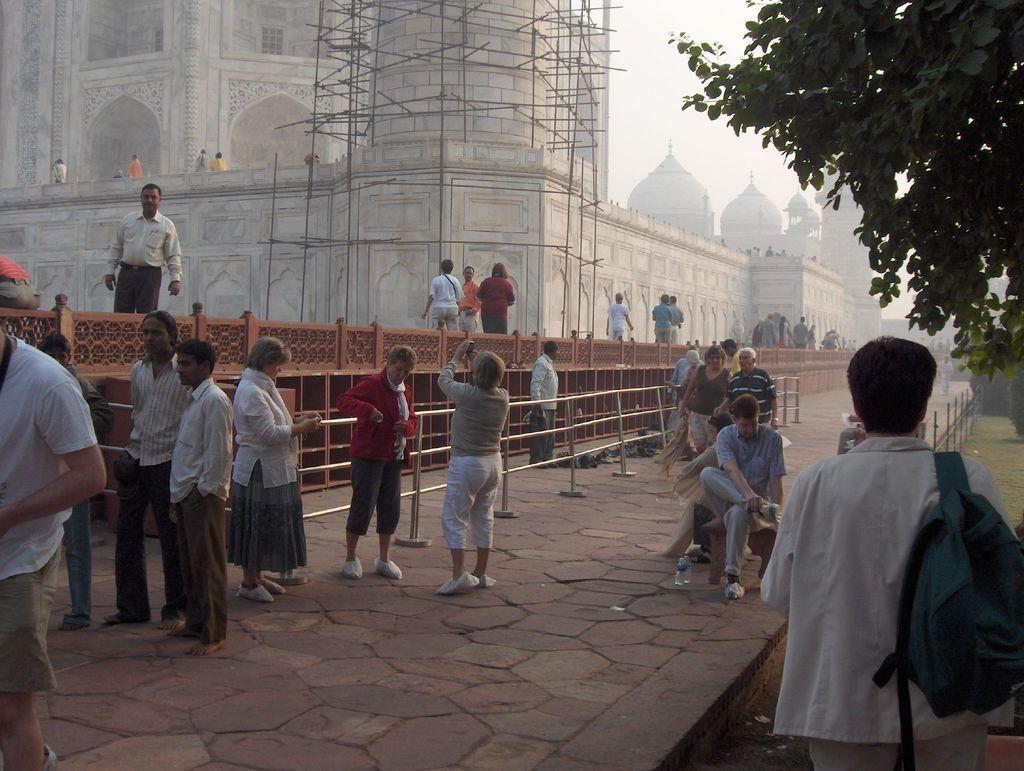Describe this image in one or two sentences. In this picture we can see a group of people,some people are sitting,some people are standing and in the background we can see buildings,trees. 